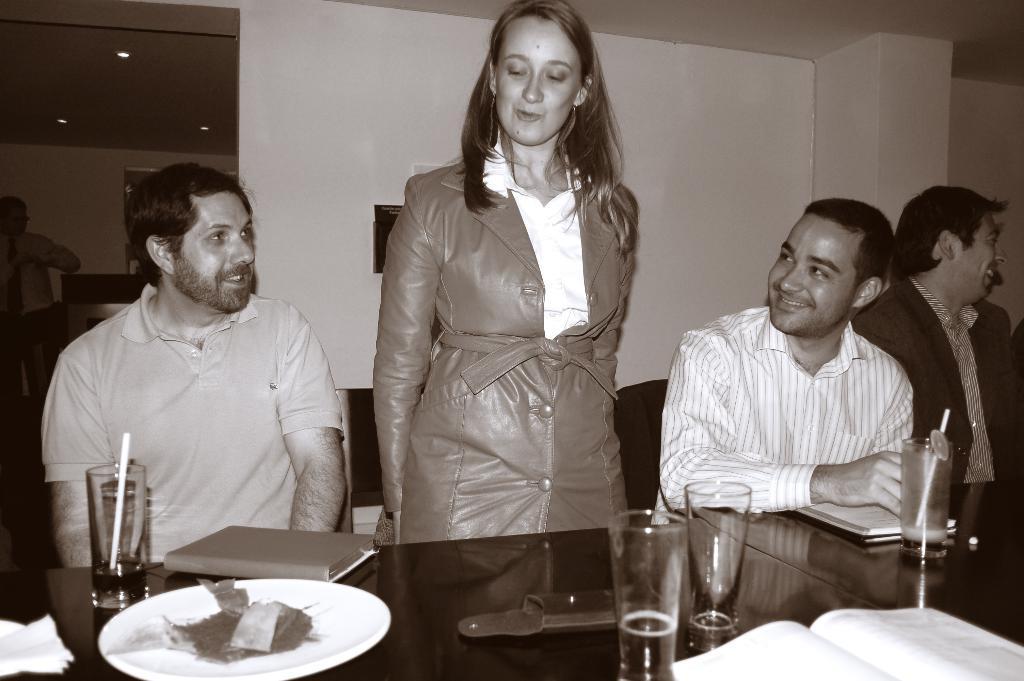Please provide a concise description of this image. In this image I can see few men are sitting on chairs and a woman is standing. Here on these tables I can see a plate, few glasses and a book. In the background I can see one more person and also I can see smile on their faces. 